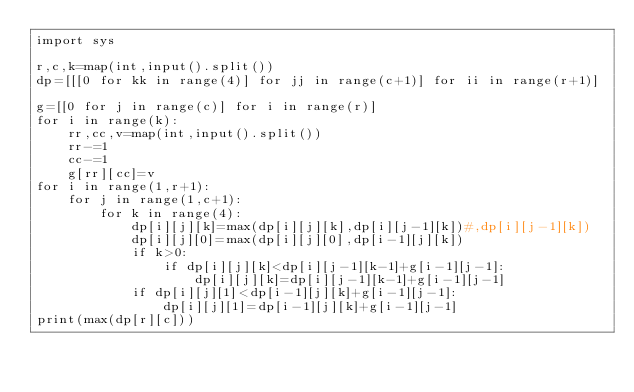<code> <loc_0><loc_0><loc_500><loc_500><_Python_>import sys

r,c,k=map(int,input().split())
dp=[[[0 for kk in range(4)] for jj in range(c+1)] for ii in range(r+1)]

g=[[0 for j in range(c)] for i in range(r)]
for i in range(k):
    rr,cc,v=map(int,input().split())
    rr-=1
    cc-=1
    g[rr][cc]=v
for i in range(1,r+1):
    for j in range(1,c+1):
        for k in range(4):
            dp[i][j][k]=max(dp[i][j][k],dp[i][j-1][k])#,dp[i][j-1][k])
            dp[i][j][0]=max(dp[i][j][0],dp[i-1][j][k])
            if k>0:
                if dp[i][j][k]<dp[i][j-1][k-1]+g[i-1][j-1]:
                    dp[i][j][k]=dp[i][j-1][k-1]+g[i-1][j-1]
            if dp[i][j][1]<dp[i-1][j][k]+g[i-1][j-1]:
                dp[i][j][1]=dp[i-1][j][k]+g[i-1][j-1]
print(max(dp[r][c]))

</code> 